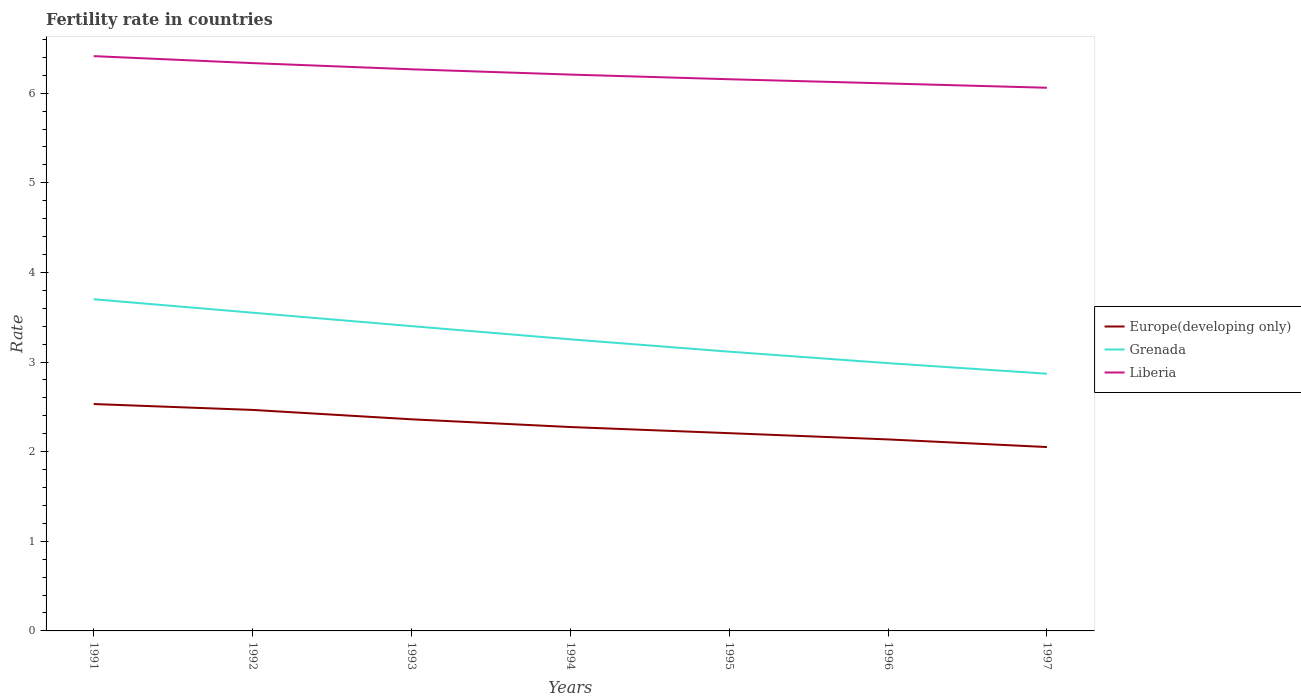Does the line corresponding to Europe(developing only) intersect with the line corresponding to Liberia?
Your response must be concise. No. Is the number of lines equal to the number of legend labels?
Provide a succinct answer. Yes. Across all years, what is the maximum fertility rate in Liberia?
Your answer should be compact. 6.06. What is the total fertility rate in Europe(developing only) in the graph?
Keep it short and to the point. 0.1. What is the difference between the highest and the second highest fertility rate in Europe(developing only)?
Provide a succinct answer. 0.48. What is the difference between the highest and the lowest fertility rate in Europe(developing only)?
Your response must be concise. 3. How many years are there in the graph?
Ensure brevity in your answer.  7. What is the difference between two consecutive major ticks on the Y-axis?
Make the answer very short. 1. Are the values on the major ticks of Y-axis written in scientific E-notation?
Your answer should be very brief. No. How many legend labels are there?
Ensure brevity in your answer.  3. How are the legend labels stacked?
Give a very brief answer. Vertical. What is the title of the graph?
Provide a succinct answer. Fertility rate in countries. Does "Bahrain" appear as one of the legend labels in the graph?
Your answer should be very brief. No. What is the label or title of the Y-axis?
Offer a very short reply. Rate. What is the Rate of Europe(developing only) in 1991?
Make the answer very short. 2.53. What is the Rate in Grenada in 1991?
Make the answer very short. 3.7. What is the Rate of Liberia in 1991?
Ensure brevity in your answer.  6.41. What is the Rate of Europe(developing only) in 1992?
Keep it short and to the point. 2.47. What is the Rate in Grenada in 1992?
Offer a terse response. 3.55. What is the Rate of Liberia in 1992?
Your answer should be compact. 6.34. What is the Rate in Europe(developing only) in 1993?
Keep it short and to the point. 2.36. What is the Rate in Grenada in 1993?
Keep it short and to the point. 3.4. What is the Rate of Liberia in 1993?
Offer a very short reply. 6.27. What is the Rate of Europe(developing only) in 1994?
Offer a terse response. 2.28. What is the Rate in Grenada in 1994?
Provide a succinct answer. 3.25. What is the Rate of Liberia in 1994?
Offer a terse response. 6.21. What is the Rate in Europe(developing only) in 1995?
Your answer should be very brief. 2.21. What is the Rate in Grenada in 1995?
Give a very brief answer. 3.12. What is the Rate in Liberia in 1995?
Your answer should be very brief. 6.16. What is the Rate of Europe(developing only) in 1996?
Your answer should be compact. 2.14. What is the Rate in Grenada in 1996?
Make the answer very short. 2.99. What is the Rate of Liberia in 1996?
Provide a succinct answer. 6.11. What is the Rate of Europe(developing only) in 1997?
Offer a terse response. 2.05. What is the Rate of Grenada in 1997?
Your response must be concise. 2.87. What is the Rate of Liberia in 1997?
Provide a succinct answer. 6.06. Across all years, what is the maximum Rate in Europe(developing only)?
Your answer should be very brief. 2.53. Across all years, what is the maximum Rate of Grenada?
Offer a terse response. 3.7. Across all years, what is the maximum Rate in Liberia?
Offer a terse response. 6.41. Across all years, what is the minimum Rate in Europe(developing only)?
Your answer should be compact. 2.05. Across all years, what is the minimum Rate of Grenada?
Make the answer very short. 2.87. Across all years, what is the minimum Rate of Liberia?
Give a very brief answer. 6.06. What is the total Rate of Europe(developing only) in the graph?
Offer a very short reply. 16.03. What is the total Rate in Grenada in the graph?
Your answer should be compact. 22.88. What is the total Rate in Liberia in the graph?
Provide a succinct answer. 43.55. What is the difference between the Rate of Europe(developing only) in 1991 and that in 1992?
Ensure brevity in your answer.  0.07. What is the difference between the Rate of Liberia in 1991 and that in 1992?
Provide a short and direct response. 0.08. What is the difference between the Rate in Europe(developing only) in 1991 and that in 1993?
Your answer should be very brief. 0.17. What is the difference between the Rate of Grenada in 1991 and that in 1993?
Your response must be concise. 0.3. What is the difference between the Rate of Liberia in 1991 and that in 1993?
Keep it short and to the point. 0.15. What is the difference between the Rate of Europe(developing only) in 1991 and that in 1994?
Your response must be concise. 0.26. What is the difference between the Rate of Grenada in 1991 and that in 1994?
Make the answer very short. 0.45. What is the difference between the Rate of Liberia in 1991 and that in 1994?
Provide a short and direct response. 0.21. What is the difference between the Rate of Europe(developing only) in 1991 and that in 1995?
Offer a very short reply. 0.33. What is the difference between the Rate in Grenada in 1991 and that in 1995?
Offer a very short reply. 0.58. What is the difference between the Rate in Liberia in 1991 and that in 1995?
Your response must be concise. 0.26. What is the difference between the Rate in Europe(developing only) in 1991 and that in 1996?
Your response must be concise. 0.39. What is the difference between the Rate of Grenada in 1991 and that in 1996?
Your response must be concise. 0.71. What is the difference between the Rate of Liberia in 1991 and that in 1996?
Ensure brevity in your answer.  0.3. What is the difference between the Rate of Europe(developing only) in 1991 and that in 1997?
Your answer should be compact. 0.48. What is the difference between the Rate of Grenada in 1991 and that in 1997?
Provide a short and direct response. 0.83. What is the difference between the Rate of Liberia in 1991 and that in 1997?
Provide a succinct answer. 0.35. What is the difference between the Rate in Europe(developing only) in 1992 and that in 1993?
Make the answer very short. 0.1. What is the difference between the Rate in Grenada in 1992 and that in 1993?
Offer a very short reply. 0.15. What is the difference between the Rate of Liberia in 1992 and that in 1993?
Your answer should be compact. 0.07. What is the difference between the Rate in Europe(developing only) in 1992 and that in 1994?
Your response must be concise. 0.19. What is the difference between the Rate in Grenada in 1992 and that in 1994?
Give a very brief answer. 0.3. What is the difference between the Rate in Liberia in 1992 and that in 1994?
Provide a short and direct response. 0.13. What is the difference between the Rate of Europe(developing only) in 1992 and that in 1995?
Give a very brief answer. 0.26. What is the difference between the Rate of Grenada in 1992 and that in 1995?
Provide a short and direct response. 0.43. What is the difference between the Rate in Liberia in 1992 and that in 1995?
Ensure brevity in your answer.  0.18. What is the difference between the Rate of Europe(developing only) in 1992 and that in 1996?
Your answer should be very brief. 0.33. What is the difference between the Rate in Grenada in 1992 and that in 1996?
Your answer should be very brief. 0.56. What is the difference between the Rate in Liberia in 1992 and that in 1996?
Your response must be concise. 0.23. What is the difference between the Rate in Europe(developing only) in 1992 and that in 1997?
Offer a very short reply. 0.41. What is the difference between the Rate in Grenada in 1992 and that in 1997?
Keep it short and to the point. 0.68. What is the difference between the Rate in Liberia in 1992 and that in 1997?
Give a very brief answer. 0.28. What is the difference between the Rate in Europe(developing only) in 1993 and that in 1994?
Offer a very short reply. 0.09. What is the difference between the Rate of Grenada in 1993 and that in 1994?
Your response must be concise. 0.15. What is the difference between the Rate of Liberia in 1993 and that in 1994?
Keep it short and to the point. 0.06. What is the difference between the Rate in Europe(developing only) in 1993 and that in 1995?
Ensure brevity in your answer.  0.15. What is the difference between the Rate in Grenada in 1993 and that in 1995?
Give a very brief answer. 0.28. What is the difference between the Rate in Liberia in 1993 and that in 1995?
Keep it short and to the point. 0.11. What is the difference between the Rate in Europe(developing only) in 1993 and that in 1996?
Give a very brief answer. 0.22. What is the difference between the Rate of Grenada in 1993 and that in 1996?
Ensure brevity in your answer.  0.41. What is the difference between the Rate of Liberia in 1993 and that in 1996?
Offer a very short reply. 0.16. What is the difference between the Rate in Europe(developing only) in 1993 and that in 1997?
Give a very brief answer. 0.31. What is the difference between the Rate in Grenada in 1993 and that in 1997?
Your response must be concise. 0.53. What is the difference between the Rate in Liberia in 1993 and that in 1997?
Your answer should be very brief. 0.21. What is the difference between the Rate of Europe(developing only) in 1994 and that in 1995?
Offer a very short reply. 0.07. What is the difference between the Rate in Grenada in 1994 and that in 1995?
Ensure brevity in your answer.  0.14. What is the difference between the Rate of Liberia in 1994 and that in 1995?
Keep it short and to the point. 0.05. What is the difference between the Rate of Europe(developing only) in 1994 and that in 1996?
Provide a succinct answer. 0.14. What is the difference between the Rate of Grenada in 1994 and that in 1996?
Provide a short and direct response. 0.27. What is the difference between the Rate of Liberia in 1994 and that in 1996?
Make the answer very short. 0.1. What is the difference between the Rate in Europe(developing only) in 1994 and that in 1997?
Provide a short and direct response. 0.22. What is the difference between the Rate of Grenada in 1994 and that in 1997?
Your response must be concise. 0.38. What is the difference between the Rate in Liberia in 1994 and that in 1997?
Make the answer very short. 0.15. What is the difference between the Rate of Europe(developing only) in 1995 and that in 1996?
Give a very brief answer. 0.07. What is the difference between the Rate of Grenada in 1995 and that in 1996?
Keep it short and to the point. 0.13. What is the difference between the Rate in Liberia in 1995 and that in 1996?
Your answer should be very brief. 0.05. What is the difference between the Rate of Europe(developing only) in 1995 and that in 1997?
Offer a very short reply. 0.15. What is the difference between the Rate in Grenada in 1995 and that in 1997?
Offer a terse response. 0.25. What is the difference between the Rate of Liberia in 1995 and that in 1997?
Give a very brief answer. 0.1. What is the difference between the Rate of Europe(developing only) in 1996 and that in 1997?
Make the answer very short. 0.09. What is the difference between the Rate of Grenada in 1996 and that in 1997?
Provide a succinct answer. 0.12. What is the difference between the Rate of Liberia in 1996 and that in 1997?
Ensure brevity in your answer.  0.05. What is the difference between the Rate of Europe(developing only) in 1991 and the Rate of Grenada in 1992?
Provide a short and direct response. -1.02. What is the difference between the Rate of Europe(developing only) in 1991 and the Rate of Liberia in 1992?
Your answer should be very brief. -3.8. What is the difference between the Rate in Grenada in 1991 and the Rate in Liberia in 1992?
Offer a very short reply. -2.63. What is the difference between the Rate in Europe(developing only) in 1991 and the Rate in Grenada in 1993?
Your answer should be very brief. -0.87. What is the difference between the Rate of Europe(developing only) in 1991 and the Rate of Liberia in 1993?
Offer a very short reply. -3.74. What is the difference between the Rate in Grenada in 1991 and the Rate in Liberia in 1993?
Your answer should be compact. -2.57. What is the difference between the Rate of Europe(developing only) in 1991 and the Rate of Grenada in 1994?
Provide a succinct answer. -0.72. What is the difference between the Rate of Europe(developing only) in 1991 and the Rate of Liberia in 1994?
Your response must be concise. -3.68. What is the difference between the Rate of Grenada in 1991 and the Rate of Liberia in 1994?
Keep it short and to the point. -2.51. What is the difference between the Rate of Europe(developing only) in 1991 and the Rate of Grenada in 1995?
Give a very brief answer. -0.58. What is the difference between the Rate in Europe(developing only) in 1991 and the Rate in Liberia in 1995?
Provide a succinct answer. -3.62. What is the difference between the Rate of Grenada in 1991 and the Rate of Liberia in 1995?
Offer a very short reply. -2.46. What is the difference between the Rate in Europe(developing only) in 1991 and the Rate in Grenada in 1996?
Give a very brief answer. -0.46. What is the difference between the Rate of Europe(developing only) in 1991 and the Rate of Liberia in 1996?
Ensure brevity in your answer.  -3.58. What is the difference between the Rate of Grenada in 1991 and the Rate of Liberia in 1996?
Offer a very short reply. -2.41. What is the difference between the Rate of Europe(developing only) in 1991 and the Rate of Grenada in 1997?
Your answer should be very brief. -0.34. What is the difference between the Rate in Europe(developing only) in 1991 and the Rate in Liberia in 1997?
Your response must be concise. -3.53. What is the difference between the Rate of Grenada in 1991 and the Rate of Liberia in 1997?
Your answer should be very brief. -2.36. What is the difference between the Rate in Europe(developing only) in 1992 and the Rate in Grenada in 1993?
Make the answer very short. -0.93. What is the difference between the Rate in Europe(developing only) in 1992 and the Rate in Liberia in 1993?
Make the answer very short. -3.8. What is the difference between the Rate of Grenada in 1992 and the Rate of Liberia in 1993?
Your response must be concise. -2.72. What is the difference between the Rate in Europe(developing only) in 1992 and the Rate in Grenada in 1994?
Offer a very short reply. -0.79. What is the difference between the Rate in Europe(developing only) in 1992 and the Rate in Liberia in 1994?
Your answer should be compact. -3.74. What is the difference between the Rate of Grenada in 1992 and the Rate of Liberia in 1994?
Provide a succinct answer. -2.66. What is the difference between the Rate of Europe(developing only) in 1992 and the Rate of Grenada in 1995?
Offer a very short reply. -0.65. What is the difference between the Rate of Europe(developing only) in 1992 and the Rate of Liberia in 1995?
Offer a very short reply. -3.69. What is the difference between the Rate in Grenada in 1992 and the Rate in Liberia in 1995?
Ensure brevity in your answer.  -2.6. What is the difference between the Rate in Europe(developing only) in 1992 and the Rate in Grenada in 1996?
Keep it short and to the point. -0.52. What is the difference between the Rate of Europe(developing only) in 1992 and the Rate of Liberia in 1996?
Give a very brief answer. -3.64. What is the difference between the Rate in Grenada in 1992 and the Rate in Liberia in 1996?
Offer a terse response. -2.56. What is the difference between the Rate of Europe(developing only) in 1992 and the Rate of Grenada in 1997?
Your answer should be compact. -0.4. What is the difference between the Rate of Europe(developing only) in 1992 and the Rate of Liberia in 1997?
Your answer should be compact. -3.59. What is the difference between the Rate in Grenada in 1992 and the Rate in Liberia in 1997?
Your answer should be very brief. -2.51. What is the difference between the Rate of Europe(developing only) in 1993 and the Rate of Grenada in 1994?
Give a very brief answer. -0.89. What is the difference between the Rate of Europe(developing only) in 1993 and the Rate of Liberia in 1994?
Ensure brevity in your answer.  -3.85. What is the difference between the Rate in Grenada in 1993 and the Rate in Liberia in 1994?
Keep it short and to the point. -2.81. What is the difference between the Rate of Europe(developing only) in 1993 and the Rate of Grenada in 1995?
Your response must be concise. -0.75. What is the difference between the Rate of Europe(developing only) in 1993 and the Rate of Liberia in 1995?
Your answer should be compact. -3.79. What is the difference between the Rate of Grenada in 1993 and the Rate of Liberia in 1995?
Provide a succinct answer. -2.75. What is the difference between the Rate of Europe(developing only) in 1993 and the Rate of Grenada in 1996?
Your answer should be compact. -0.63. What is the difference between the Rate of Europe(developing only) in 1993 and the Rate of Liberia in 1996?
Offer a terse response. -3.75. What is the difference between the Rate of Grenada in 1993 and the Rate of Liberia in 1996?
Keep it short and to the point. -2.71. What is the difference between the Rate of Europe(developing only) in 1993 and the Rate of Grenada in 1997?
Provide a short and direct response. -0.51. What is the difference between the Rate in Europe(developing only) in 1993 and the Rate in Liberia in 1997?
Your answer should be compact. -3.7. What is the difference between the Rate of Grenada in 1993 and the Rate of Liberia in 1997?
Offer a terse response. -2.66. What is the difference between the Rate of Europe(developing only) in 1994 and the Rate of Grenada in 1995?
Offer a terse response. -0.84. What is the difference between the Rate of Europe(developing only) in 1994 and the Rate of Liberia in 1995?
Offer a very short reply. -3.88. What is the difference between the Rate in Grenada in 1994 and the Rate in Liberia in 1995?
Your answer should be compact. -2.9. What is the difference between the Rate in Europe(developing only) in 1994 and the Rate in Grenada in 1996?
Your answer should be compact. -0.71. What is the difference between the Rate of Europe(developing only) in 1994 and the Rate of Liberia in 1996?
Make the answer very short. -3.83. What is the difference between the Rate in Grenada in 1994 and the Rate in Liberia in 1996?
Provide a succinct answer. -2.85. What is the difference between the Rate in Europe(developing only) in 1994 and the Rate in Grenada in 1997?
Provide a succinct answer. -0.59. What is the difference between the Rate in Europe(developing only) in 1994 and the Rate in Liberia in 1997?
Offer a very short reply. -3.79. What is the difference between the Rate in Grenada in 1994 and the Rate in Liberia in 1997?
Keep it short and to the point. -2.81. What is the difference between the Rate in Europe(developing only) in 1995 and the Rate in Grenada in 1996?
Offer a very short reply. -0.78. What is the difference between the Rate in Europe(developing only) in 1995 and the Rate in Liberia in 1996?
Keep it short and to the point. -3.9. What is the difference between the Rate in Grenada in 1995 and the Rate in Liberia in 1996?
Offer a terse response. -2.99. What is the difference between the Rate in Europe(developing only) in 1995 and the Rate in Grenada in 1997?
Provide a succinct answer. -0.66. What is the difference between the Rate of Europe(developing only) in 1995 and the Rate of Liberia in 1997?
Give a very brief answer. -3.85. What is the difference between the Rate in Grenada in 1995 and the Rate in Liberia in 1997?
Offer a very short reply. -2.94. What is the difference between the Rate of Europe(developing only) in 1996 and the Rate of Grenada in 1997?
Your answer should be compact. -0.73. What is the difference between the Rate in Europe(developing only) in 1996 and the Rate in Liberia in 1997?
Make the answer very short. -3.92. What is the difference between the Rate of Grenada in 1996 and the Rate of Liberia in 1997?
Give a very brief answer. -3.07. What is the average Rate of Europe(developing only) per year?
Give a very brief answer. 2.29. What is the average Rate in Grenada per year?
Offer a terse response. 3.27. What is the average Rate in Liberia per year?
Your answer should be compact. 6.22. In the year 1991, what is the difference between the Rate of Europe(developing only) and Rate of Grenada?
Give a very brief answer. -1.17. In the year 1991, what is the difference between the Rate in Europe(developing only) and Rate in Liberia?
Offer a terse response. -3.88. In the year 1991, what is the difference between the Rate in Grenada and Rate in Liberia?
Provide a succinct answer. -2.71. In the year 1992, what is the difference between the Rate in Europe(developing only) and Rate in Grenada?
Make the answer very short. -1.08. In the year 1992, what is the difference between the Rate of Europe(developing only) and Rate of Liberia?
Your answer should be compact. -3.87. In the year 1992, what is the difference between the Rate in Grenada and Rate in Liberia?
Give a very brief answer. -2.79. In the year 1993, what is the difference between the Rate of Europe(developing only) and Rate of Grenada?
Provide a succinct answer. -1.04. In the year 1993, what is the difference between the Rate in Europe(developing only) and Rate in Liberia?
Give a very brief answer. -3.91. In the year 1993, what is the difference between the Rate of Grenada and Rate of Liberia?
Offer a terse response. -2.87. In the year 1994, what is the difference between the Rate in Europe(developing only) and Rate in Grenada?
Provide a short and direct response. -0.98. In the year 1994, what is the difference between the Rate of Europe(developing only) and Rate of Liberia?
Offer a very short reply. -3.93. In the year 1994, what is the difference between the Rate in Grenada and Rate in Liberia?
Provide a short and direct response. -2.95. In the year 1995, what is the difference between the Rate in Europe(developing only) and Rate in Grenada?
Give a very brief answer. -0.91. In the year 1995, what is the difference between the Rate of Europe(developing only) and Rate of Liberia?
Offer a very short reply. -3.95. In the year 1995, what is the difference between the Rate in Grenada and Rate in Liberia?
Offer a very short reply. -3.04. In the year 1996, what is the difference between the Rate of Europe(developing only) and Rate of Grenada?
Your answer should be compact. -0.85. In the year 1996, what is the difference between the Rate of Europe(developing only) and Rate of Liberia?
Ensure brevity in your answer.  -3.97. In the year 1996, what is the difference between the Rate of Grenada and Rate of Liberia?
Ensure brevity in your answer.  -3.12. In the year 1997, what is the difference between the Rate of Europe(developing only) and Rate of Grenada?
Give a very brief answer. -0.82. In the year 1997, what is the difference between the Rate of Europe(developing only) and Rate of Liberia?
Provide a succinct answer. -4.01. In the year 1997, what is the difference between the Rate of Grenada and Rate of Liberia?
Give a very brief answer. -3.19. What is the ratio of the Rate of Europe(developing only) in 1991 to that in 1992?
Ensure brevity in your answer.  1.03. What is the ratio of the Rate of Grenada in 1991 to that in 1992?
Keep it short and to the point. 1.04. What is the ratio of the Rate of Liberia in 1991 to that in 1992?
Your answer should be compact. 1.01. What is the ratio of the Rate in Europe(developing only) in 1991 to that in 1993?
Your answer should be very brief. 1.07. What is the ratio of the Rate of Grenada in 1991 to that in 1993?
Your response must be concise. 1.09. What is the ratio of the Rate in Liberia in 1991 to that in 1993?
Provide a short and direct response. 1.02. What is the ratio of the Rate of Europe(developing only) in 1991 to that in 1994?
Ensure brevity in your answer.  1.11. What is the ratio of the Rate of Grenada in 1991 to that in 1994?
Make the answer very short. 1.14. What is the ratio of the Rate in Liberia in 1991 to that in 1994?
Ensure brevity in your answer.  1.03. What is the ratio of the Rate of Europe(developing only) in 1991 to that in 1995?
Offer a terse response. 1.15. What is the ratio of the Rate of Grenada in 1991 to that in 1995?
Your answer should be compact. 1.19. What is the ratio of the Rate in Liberia in 1991 to that in 1995?
Ensure brevity in your answer.  1.04. What is the ratio of the Rate in Europe(developing only) in 1991 to that in 1996?
Make the answer very short. 1.18. What is the ratio of the Rate of Grenada in 1991 to that in 1996?
Make the answer very short. 1.24. What is the ratio of the Rate in Liberia in 1991 to that in 1996?
Provide a succinct answer. 1.05. What is the ratio of the Rate of Europe(developing only) in 1991 to that in 1997?
Offer a terse response. 1.23. What is the ratio of the Rate in Grenada in 1991 to that in 1997?
Your answer should be very brief. 1.29. What is the ratio of the Rate of Liberia in 1991 to that in 1997?
Give a very brief answer. 1.06. What is the ratio of the Rate of Europe(developing only) in 1992 to that in 1993?
Offer a terse response. 1.04. What is the ratio of the Rate of Grenada in 1992 to that in 1993?
Offer a terse response. 1.04. What is the ratio of the Rate in Liberia in 1992 to that in 1993?
Your answer should be very brief. 1.01. What is the ratio of the Rate of Europe(developing only) in 1992 to that in 1994?
Provide a succinct answer. 1.08. What is the ratio of the Rate in Grenada in 1992 to that in 1994?
Make the answer very short. 1.09. What is the ratio of the Rate of Liberia in 1992 to that in 1994?
Offer a very short reply. 1.02. What is the ratio of the Rate of Europe(developing only) in 1992 to that in 1995?
Offer a very short reply. 1.12. What is the ratio of the Rate in Grenada in 1992 to that in 1995?
Offer a very short reply. 1.14. What is the ratio of the Rate of Liberia in 1992 to that in 1995?
Offer a terse response. 1.03. What is the ratio of the Rate of Europe(developing only) in 1992 to that in 1996?
Provide a succinct answer. 1.15. What is the ratio of the Rate of Grenada in 1992 to that in 1996?
Make the answer very short. 1.19. What is the ratio of the Rate of Liberia in 1992 to that in 1996?
Your answer should be compact. 1.04. What is the ratio of the Rate in Europe(developing only) in 1992 to that in 1997?
Provide a short and direct response. 1.2. What is the ratio of the Rate of Grenada in 1992 to that in 1997?
Your answer should be very brief. 1.24. What is the ratio of the Rate of Liberia in 1992 to that in 1997?
Keep it short and to the point. 1.05. What is the ratio of the Rate of Europe(developing only) in 1993 to that in 1994?
Make the answer very short. 1.04. What is the ratio of the Rate in Grenada in 1993 to that in 1994?
Offer a very short reply. 1.05. What is the ratio of the Rate in Liberia in 1993 to that in 1994?
Give a very brief answer. 1.01. What is the ratio of the Rate in Europe(developing only) in 1993 to that in 1995?
Keep it short and to the point. 1.07. What is the ratio of the Rate in Grenada in 1993 to that in 1995?
Offer a terse response. 1.09. What is the ratio of the Rate of Europe(developing only) in 1993 to that in 1996?
Offer a very short reply. 1.1. What is the ratio of the Rate of Grenada in 1993 to that in 1996?
Provide a short and direct response. 1.14. What is the ratio of the Rate of Liberia in 1993 to that in 1996?
Make the answer very short. 1.03. What is the ratio of the Rate of Europe(developing only) in 1993 to that in 1997?
Offer a very short reply. 1.15. What is the ratio of the Rate of Grenada in 1993 to that in 1997?
Keep it short and to the point. 1.19. What is the ratio of the Rate in Liberia in 1993 to that in 1997?
Your answer should be compact. 1.03. What is the ratio of the Rate of Europe(developing only) in 1994 to that in 1995?
Your answer should be compact. 1.03. What is the ratio of the Rate in Grenada in 1994 to that in 1995?
Provide a succinct answer. 1.04. What is the ratio of the Rate in Liberia in 1994 to that in 1995?
Your answer should be very brief. 1.01. What is the ratio of the Rate of Europe(developing only) in 1994 to that in 1996?
Your answer should be compact. 1.06. What is the ratio of the Rate of Grenada in 1994 to that in 1996?
Your answer should be very brief. 1.09. What is the ratio of the Rate in Liberia in 1994 to that in 1996?
Provide a short and direct response. 1.02. What is the ratio of the Rate of Europe(developing only) in 1994 to that in 1997?
Your answer should be compact. 1.11. What is the ratio of the Rate in Grenada in 1994 to that in 1997?
Provide a succinct answer. 1.13. What is the ratio of the Rate in Liberia in 1994 to that in 1997?
Ensure brevity in your answer.  1.02. What is the ratio of the Rate of Europe(developing only) in 1995 to that in 1996?
Make the answer very short. 1.03. What is the ratio of the Rate of Grenada in 1995 to that in 1996?
Your answer should be very brief. 1.04. What is the ratio of the Rate of Liberia in 1995 to that in 1996?
Give a very brief answer. 1.01. What is the ratio of the Rate of Europe(developing only) in 1995 to that in 1997?
Make the answer very short. 1.08. What is the ratio of the Rate in Grenada in 1995 to that in 1997?
Give a very brief answer. 1.09. What is the ratio of the Rate in Liberia in 1995 to that in 1997?
Your response must be concise. 1.02. What is the ratio of the Rate of Europe(developing only) in 1996 to that in 1997?
Keep it short and to the point. 1.04. What is the ratio of the Rate in Grenada in 1996 to that in 1997?
Your response must be concise. 1.04. What is the ratio of the Rate in Liberia in 1996 to that in 1997?
Offer a terse response. 1.01. What is the difference between the highest and the second highest Rate of Europe(developing only)?
Your answer should be compact. 0.07. What is the difference between the highest and the second highest Rate of Liberia?
Provide a succinct answer. 0.08. What is the difference between the highest and the lowest Rate in Europe(developing only)?
Make the answer very short. 0.48. What is the difference between the highest and the lowest Rate of Grenada?
Give a very brief answer. 0.83. What is the difference between the highest and the lowest Rate in Liberia?
Provide a short and direct response. 0.35. 